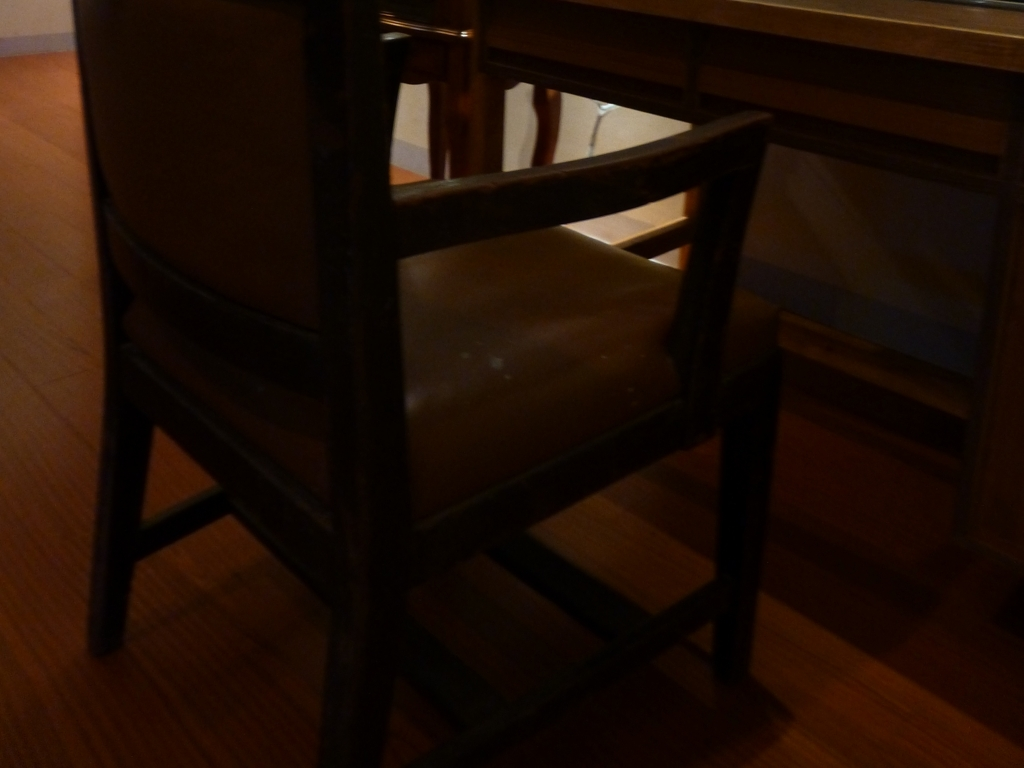Can you describe what is visible in the image despite its poor quality? Despite the poor lighting, one can discern a chair situated next to a wooden desk or table. The environment suggests an interior space, possibly a home or office with wooden flooring. 